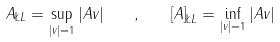Convert formula to latex. <formula><loc_0><loc_0><loc_500><loc_500>\| A \| _ { \L L } = \sup _ { | v | = 1 } | A v | \quad , \quad \left [ A \right ] _ { \L L } = \inf _ { | v | = 1 } | A v |</formula> 